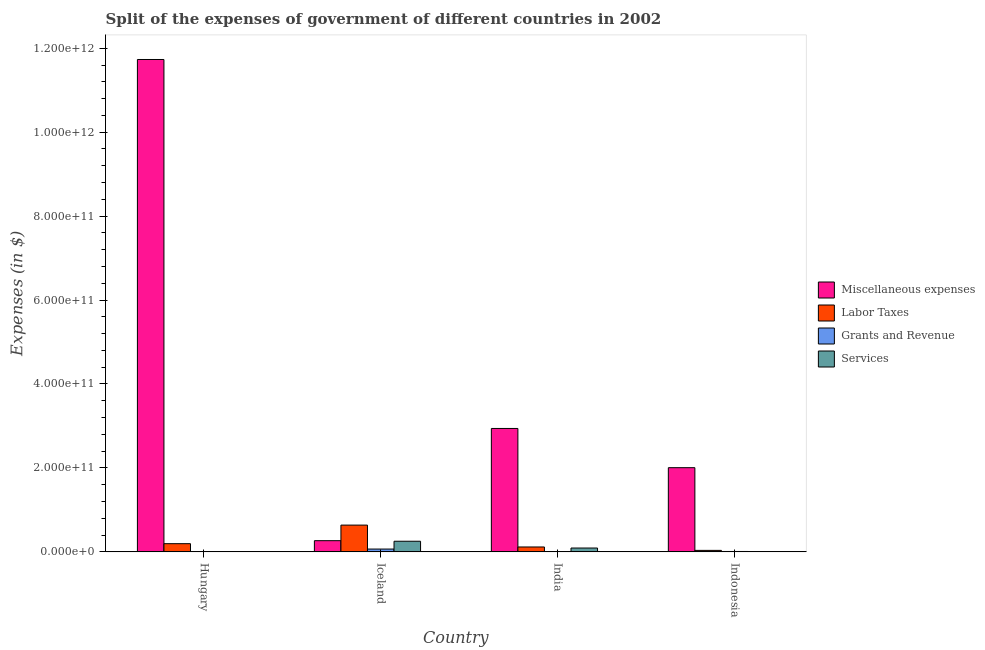How many groups of bars are there?
Provide a succinct answer. 4. Are the number of bars per tick equal to the number of legend labels?
Provide a succinct answer. Yes. Are the number of bars on each tick of the X-axis equal?
Provide a short and direct response. Yes. How many bars are there on the 1st tick from the left?
Provide a succinct answer. 4. How many bars are there on the 4th tick from the right?
Provide a succinct answer. 4. What is the label of the 1st group of bars from the left?
Ensure brevity in your answer.  Hungary. What is the amount spent on miscellaneous expenses in Indonesia?
Ensure brevity in your answer.  2.01e+11. Across all countries, what is the maximum amount spent on labor taxes?
Make the answer very short. 6.38e+1. Across all countries, what is the minimum amount spent on services?
Your response must be concise. 4.75e+07. What is the total amount spent on services in the graph?
Offer a terse response. 3.47e+1. What is the difference between the amount spent on labor taxes in India and that in Indonesia?
Give a very brief answer. 8.11e+09. What is the difference between the amount spent on miscellaneous expenses in Indonesia and the amount spent on services in Iceland?
Offer a very short reply. 1.75e+11. What is the average amount spent on services per country?
Keep it short and to the point. 8.68e+09. What is the difference between the amount spent on labor taxes and amount spent on miscellaneous expenses in Hungary?
Your response must be concise. -1.15e+12. What is the ratio of the amount spent on grants and revenue in Hungary to that in Iceland?
Make the answer very short. 0.03. Is the amount spent on miscellaneous expenses in Hungary less than that in Iceland?
Your answer should be compact. No. What is the difference between the highest and the second highest amount spent on labor taxes?
Your answer should be compact. 4.42e+1. What is the difference between the highest and the lowest amount spent on labor taxes?
Your response must be concise. 6.02e+1. In how many countries, is the amount spent on labor taxes greater than the average amount spent on labor taxes taken over all countries?
Make the answer very short. 1. Is it the case that in every country, the sum of the amount spent on miscellaneous expenses and amount spent on labor taxes is greater than the sum of amount spent on grants and revenue and amount spent on services?
Make the answer very short. No. What does the 1st bar from the left in Iceland represents?
Your response must be concise. Miscellaneous expenses. What does the 3rd bar from the right in India represents?
Give a very brief answer. Labor Taxes. How many bars are there?
Offer a very short reply. 16. Are all the bars in the graph horizontal?
Keep it short and to the point. No. How many countries are there in the graph?
Your response must be concise. 4. What is the difference between two consecutive major ticks on the Y-axis?
Your answer should be compact. 2.00e+11. Does the graph contain any zero values?
Keep it short and to the point. No. Where does the legend appear in the graph?
Your answer should be compact. Center right. How many legend labels are there?
Keep it short and to the point. 4. What is the title of the graph?
Offer a terse response. Split of the expenses of government of different countries in 2002. What is the label or title of the X-axis?
Offer a terse response. Country. What is the label or title of the Y-axis?
Give a very brief answer. Expenses (in $). What is the Expenses (in $) of Miscellaneous expenses in Hungary?
Give a very brief answer. 1.17e+12. What is the Expenses (in $) of Labor Taxes in Hungary?
Give a very brief answer. 1.95e+1. What is the Expenses (in $) of Grants and Revenue in Hungary?
Provide a short and direct response. 1.78e+08. What is the Expenses (in $) in Services in Hungary?
Offer a terse response. 1.82e+08. What is the Expenses (in $) of Miscellaneous expenses in Iceland?
Offer a terse response. 2.67e+1. What is the Expenses (in $) of Labor Taxes in Iceland?
Ensure brevity in your answer.  6.38e+1. What is the Expenses (in $) of Grants and Revenue in Iceland?
Offer a terse response. 6.73e+09. What is the Expenses (in $) of Services in Iceland?
Ensure brevity in your answer.  2.53e+1. What is the Expenses (in $) in Miscellaneous expenses in India?
Provide a succinct answer. 2.94e+11. What is the Expenses (in $) in Labor Taxes in India?
Provide a short and direct response. 1.17e+1. What is the Expenses (in $) in Grants and Revenue in India?
Offer a terse response. 5.36e+07. What is the Expenses (in $) of Services in India?
Offer a terse response. 9.18e+09. What is the Expenses (in $) of Miscellaneous expenses in Indonesia?
Make the answer very short. 2.01e+11. What is the Expenses (in $) in Labor Taxes in Indonesia?
Give a very brief answer. 3.57e+09. What is the Expenses (in $) of Grants and Revenue in Indonesia?
Your answer should be compact. 9.40e+08. What is the Expenses (in $) of Services in Indonesia?
Ensure brevity in your answer.  4.75e+07. Across all countries, what is the maximum Expenses (in $) in Miscellaneous expenses?
Provide a short and direct response. 1.17e+12. Across all countries, what is the maximum Expenses (in $) of Labor Taxes?
Your answer should be compact. 6.38e+1. Across all countries, what is the maximum Expenses (in $) of Grants and Revenue?
Make the answer very short. 6.73e+09. Across all countries, what is the maximum Expenses (in $) of Services?
Make the answer very short. 2.53e+1. Across all countries, what is the minimum Expenses (in $) in Miscellaneous expenses?
Your response must be concise. 2.67e+1. Across all countries, what is the minimum Expenses (in $) of Labor Taxes?
Provide a short and direct response. 3.57e+09. Across all countries, what is the minimum Expenses (in $) in Grants and Revenue?
Provide a succinct answer. 5.36e+07. Across all countries, what is the minimum Expenses (in $) in Services?
Provide a short and direct response. 4.75e+07. What is the total Expenses (in $) in Miscellaneous expenses in the graph?
Make the answer very short. 1.69e+12. What is the total Expenses (in $) of Labor Taxes in the graph?
Offer a very short reply. 9.86e+1. What is the total Expenses (in $) in Grants and Revenue in the graph?
Offer a very short reply. 7.90e+09. What is the total Expenses (in $) in Services in the graph?
Provide a succinct answer. 3.47e+1. What is the difference between the Expenses (in $) in Miscellaneous expenses in Hungary and that in Iceland?
Offer a terse response. 1.15e+12. What is the difference between the Expenses (in $) of Labor Taxes in Hungary and that in Iceland?
Give a very brief answer. -4.42e+1. What is the difference between the Expenses (in $) of Grants and Revenue in Hungary and that in Iceland?
Your answer should be compact. -6.55e+09. What is the difference between the Expenses (in $) of Services in Hungary and that in Iceland?
Your answer should be compact. -2.51e+1. What is the difference between the Expenses (in $) of Miscellaneous expenses in Hungary and that in India?
Provide a short and direct response. 8.79e+11. What is the difference between the Expenses (in $) in Labor Taxes in Hungary and that in India?
Ensure brevity in your answer.  7.86e+09. What is the difference between the Expenses (in $) in Grants and Revenue in Hungary and that in India?
Make the answer very short. 1.24e+08. What is the difference between the Expenses (in $) in Services in Hungary and that in India?
Your answer should be compact. -9.00e+09. What is the difference between the Expenses (in $) in Miscellaneous expenses in Hungary and that in Indonesia?
Give a very brief answer. 9.73e+11. What is the difference between the Expenses (in $) of Labor Taxes in Hungary and that in Indonesia?
Make the answer very short. 1.60e+1. What is the difference between the Expenses (in $) of Grants and Revenue in Hungary and that in Indonesia?
Your answer should be compact. -7.63e+08. What is the difference between the Expenses (in $) of Services in Hungary and that in Indonesia?
Your answer should be very brief. 1.35e+08. What is the difference between the Expenses (in $) of Miscellaneous expenses in Iceland and that in India?
Your answer should be compact. -2.67e+11. What is the difference between the Expenses (in $) of Labor Taxes in Iceland and that in India?
Provide a short and direct response. 5.21e+1. What is the difference between the Expenses (in $) in Grants and Revenue in Iceland and that in India?
Your response must be concise. 6.67e+09. What is the difference between the Expenses (in $) in Services in Iceland and that in India?
Provide a short and direct response. 1.61e+1. What is the difference between the Expenses (in $) in Miscellaneous expenses in Iceland and that in Indonesia?
Keep it short and to the point. -1.74e+11. What is the difference between the Expenses (in $) of Labor Taxes in Iceland and that in Indonesia?
Offer a terse response. 6.02e+1. What is the difference between the Expenses (in $) in Grants and Revenue in Iceland and that in Indonesia?
Your response must be concise. 5.79e+09. What is the difference between the Expenses (in $) in Services in Iceland and that in Indonesia?
Offer a very short reply. 2.53e+1. What is the difference between the Expenses (in $) in Miscellaneous expenses in India and that in Indonesia?
Give a very brief answer. 9.34e+1. What is the difference between the Expenses (in $) in Labor Taxes in India and that in Indonesia?
Provide a short and direct response. 8.11e+09. What is the difference between the Expenses (in $) in Grants and Revenue in India and that in Indonesia?
Keep it short and to the point. -8.87e+08. What is the difference between the Expenses (in $) in Services in India and that in Indonesia?
Ensure brevity in your answer.  9.13e+09. What is the difference between the Expenses (in $) of Miscellaneous expenses in Hungary and the Expenses (in $) of Labor Taxes in Iceland?
Ensure brevity in your answer.  1.11e+12. What is the difference between the Expenses (in $) of Miscellaneous expenses in Hungary and the Expenses (in $) of Grants and Revenue in Iceland?
Your answer should be compact. 1.17e+12. What is the difference between the Expenses (in $) in Miscellaneous expenses in Hungary and the Expenses (in $) in Services in Iceland?
Make the answer very short. 1.15e+12. What is the difference between the Expenses (in $) of Labor Taxes in Hungary and the Expenses (in $) of Grants and Revenue in Iceland?
Provide a short and direct response. 1.28e+1. What is the difference between the Expenses (in $) of Labor Taxes in Hungary and the Expenses (in $) of Services in Iceland?
Make the answer very short. -5.78e+09. What is the difference between the Expenses (in $) of Grants and Revenue in Hungary and the Expenses (in $) of Services in Iceland?
Offer a terse response. -2.51e+1. What is the difference between the Expenses (in $) of Miscellaneous expenses in Hungary and the Expenses (in $) of Labor Taxes in India?
Your answer should be compact. 1.16e+12. What is the difference between the Expenses (in $) in Miscellaneous expenses in Hungary and the Expenses (in $) in Grants and Revenue in India?
Provide a short and direct response. 1.17e+12. What is the difference between the Expenses (in $) of Miscellaneous expenses in Hungary and the Expenses (in $) of Services in India?
Your answer should be very brief. 1.16e+12. What is the difference between the Expenses (in $) of Labor Taxes in Hungary and the Expenses (in $) of Grants and Revenue in India?
Your response must be concise. 1.95e+1. What is the difference between the Expenses (in $) of Labor Taxes in Hungary and the Expenses (in $) of Services in India?
Ensure brevity in your answer.  1.04e+1. What is the difference between the Expenses (in $) in Grants and Revenue in Hungary and the Expenses (in $) in Services in India?
Your answer should be compact. -9.00e+09. What is the difference between the Expenses (in $) of Miscellaneous expenses in Hungary and the Expenses (in $) of Labor Taxes in Indonesia?
Your response must be concise. 1.17e+12. What is the difference between the Expenses (in $) in Miscellaneous expenses in Hungary and the Expenses (in $) in Grants and Revenue in Indonesia?
Keep it short and to the point. 1.17e+12. What is the difference between the Expenses (in $) in Miscellaneous expenses in Hungary and the Expenses (in $) in Services in Indonesia?
Provide a succinct answer. 1.17e+12. What is the difference between the Expenses (in $) in Labor Taxes in Hungary and the Expenses (in $) in Grants and Revenue in Indonesia?
Your response must be concise. 1.86e+1. What is the difference between the Expenses (in $) of Labor Taxes in Hungary and the Expenses (in $) of Services in Indonesia?
Your response must be concise. 1.95e+1. What is the difference between the Expenses (in $) in Grants and Revenue in Hungary and the Expenses (in $) in Services in Indonesia?
Offer a terse response. 1.30e+08. What is the difference between the Expenses (in $) of Miscellaneous expenses in Iceland and the Expenses (in $) of Labor Taxes in India?
Provide a short and direct response. 1.50e+1. What is the difference between the Expenses (in $) of Miscellaneous expenses in Iceland and the Expenses (in $) of Grants and Revenue in India?
Your response must be concise. 2.66e+1. What is the difference between the Expenses (in $) in Miscellaneous expenses in Iceland and the Expenses (in $) in Services in India?
Provide a succinct answer. 1.75e+1. What is the difference between the Expenses (in $) in Labor Taxes in Iceland and the Expenses (in $) in Grants and Revenue in India?
Offer a very short reply. 6.37e+1. What is the difference between the Expenses (in $) in Labor Taxes in Iceland and the Expenses (in $) in Services in India?
Provide a succinct answer. 5.46e+1. What is the difference between the Expenses (in $) of Grants and Revenue in Iceland and the Expenses (in $) of Services in India?
Provide a succinct answer. -2.46e+09. What is the difference between the Expenses (in $) in Miscellaneous expenses in Iceland and the Expenses (in $) in Labor Taxes in Indonesia?
Offer a very short reply. 2.31e+1. What is the difference between the Expenses (in $) in Miscellaneous expenses in Iceland and the Expenses (in $) in Grants and Revenue in Indonesia?
Make the answer very short. 2.57e+1. What is the difference between the Expenses (in $) of Miscellaneous expenses in Iceland and the Expenses (in $) of Services in Indonesia?
Provide a succinct answer. 2.66e+1. What is the difference between the Expenses (in $) of Labor Taxes in Iceland and the Expenses (in $) of Grants and Revenue in Indonesia?
Offer a terse response. 6.28e+1. What is the difference between the Expenses (in $) in Labor Taxes in Iceland and the Expenses (in $) in Services in Indonesia?
Offer a terse response. 6.37e+1. What is the difference between the Expenses (in $) of Grants and Revenue in Iceland and the Expenses (in $) of Services in Indonesia?
Make the answer very short. 6.68e+09. What is the difference between the Expenses (in $) in Miscellaneous expenses in India and the Expenses (in $) in Labor Taxes in Indonesia?
Your answer should be compact. 2.90e+11. What is the difference between the Expenses (in $) of Miscellaneous expenses in India and the Expenses (in $) of Grants and Revenue in Indonesia?
Provide a succinct answer. 2.93e+11. What is the difference between the Expenses (in $) in Miscellaneous expenses in India and the Expenses (in $) in Services in Indonesia?
Offer a terse response. 2.94e+11. What is the difference between the Expenses (in $) of Labor Taxes in India and the Expenses (in $) of Grants and Revenue in Indonesia?
Keep it short and to the point. 1.07e+1. What is the difference between the Expenses (in $) of Labor Taxes in India and the Expenses (in $) of Services in Indonesia?
Keep it short and to the point. 1.16e+1. What is the difference between the Expenses (in $) in Grants and Revenue in India and the Expenses (in $) in Services in Indonesia?
Ensure brevity in your answer.  6.10e+06. What is the average Expenses (in $) of Miscellaneous expenses per country?
Ensure brevity in your answer.  4.24e+11. What is the average Expenses (in $) of Labor Taxes per country?
Make the answer very short. 2.46e+1. What is the average Expenses (in $) of Grants and Revenue per country?
Offer a very short reply. 1.97e+09. What is the average Expenses (in $) in Services per country?
Make the answer very short. 8.68e+09. What is the difference between the Expenses (in $) in Miscellaneous expenses and Expenses (in $) in Labor Taxes in Hungary?
Your answer should be compact. 1.15e+12. What is the difference between the Expenses (in $) of Miscellaneous expenses and Expenses (in $) of Grants and Revenue in Hungary?
Keep it short and to the point. 1.17e+12. What is the difference between the Expenses (in $) of Miscellaneous expenses and Expenses (in $) of Services in Hungary?
Keep it short and to the point. 1.17e+12. What is the difference between the Expenses (in $) of Labor Taxes and Expenses (in $) of Grants and Revenue in Hungary?
Offer a terse response. 1.94e+1. What is the difference between the Expenses (in $) in Labor Taxes and Expenses (in $) in Services in Hungary?
Make the answer very short. 1.94e+1. What is the difference between the Expenses (in $) of Grants and Revenue and Expenses (in $) of Services in Hungary?
Your answer should be compact. -4.40e+06. What is the difference between the Expenses (in $) of Miscellaneous expenses and Expenses (in $) of Labor Taxes in Iceland?
Your answer should be compact. -3.71e+1. What is the difference between the Expenses (in $) in Miscellaneous expenses and Expenses (in $) in Grants and Revenue in Iceland?
Provide a succinct answer. 1.99e+1. What is the difference between the Expenses (in $) of Miscellaneous expenses and Expenses (in $) of Services in Iceland?
Offer a terse response. 1.34e+09. What is the difference between the Expenses (in $) in Labor Taxes and Expenses (in $) in Grants and Revenue in Iceland?
Your answer should be compact. 5.70e+1. What is the difference between the Expenses (in $) of Labor Taxes and Expenses (in $) of Services in Iceland?
Make the answer very short. 3.85e+1. What is the difference between the Expenses (in $) in Grants and Revenue and Expenses (in $) in Services in Iceland?
Offer a terse response. -1.86e+1. What is the difference between the Expenses (in $) of Miscellaneous expenses and Expenses (in $) of Labor Taxes in India?
Your response must be concise. 2.82e+11. What is the difference between the Expenses (in $) in Miscellaneous expenses and Expenses (in $) in Grants and Revenue in India?
Offer a terse response. 2.94e+11. What is the difference between the Expenses (in $) in Miscellaneous expenses and Expenses (in $) in Services in India?
Offer a very short reply. 2.85e+11. What is the difference between the Expenses (in $) in Labor Taxes and Expenses (in $) in Grants and Revenue in India?
Your answer should be very brief. 1.16e+1. What is the difference between the Expenses (in $) of Labor Taxes and Expenses (in $) of Services in India?
Offer a very short reply. 2.50e+09. What is the difference between the Expenses (in $) in Grants and Revenue and Expenses (in $) in Services in India?
Provide a succinct answer. -9.13e+09. What is the difference between the Expenses (in $) in Miscellaneous expenses and Expenses (in $) in Labor Taxes in Indonesia?
Provide a short and direct response. 1.97e+11. What is the difference between the Expenses (in $) in Miscellaneous expenses and Expenses (in $) in Grants and Revenue in Indonesia?
Provide a short and direct response. 2.00e+11. What is the difference between the Expenses (in $) of Miscellaneous expenses and Expenses (in $) of Services in Indonesia?
Offer a terse response. 2.01e+11. What is the difference between the Expenses (in $) in Labor Taxes and Expenses (in $) in Grants and Revenue in Indonesia?
Ensure brevity in your answer.  2.63e+09. What is the difference between the Expenses (in $) in Labor Taxes and Expenses (in $) in Services in Indonesia?
Offer a terse response. 3.52e+09. What is the difference between the Expenses (in $) in Grants and Revenue and Expenses (in $) in Services in Indonesia?
Provide a succinct answer. 8.93e+08. What is the ratio of the Expenses (in $) in Miscellaneous expenses in Hungary to that in Iceland?
Provide a short and direct response. 44.01. What is the ratio of the Expenses (in $) of Labor Taxes in Hungary to that in Iceland?
Your answer should be compact. 0.31. What is the ratio of the Expenses (in $) of Grants and Revenue in Hungary to that in Iceland?
Your response must be concise. 0.03. What is the ratio of the Expenses (in $) of Services in Hungary to that in Iceland?
Provide a succinct answer. 0.01. What is the ratio of the Expenses (in $) of Miscellaneous expenses in Hungary to that in India?
Keep it short and to the point. 3.99. What is the ratio of the Expenses (in $) in Labor Taxes in Hungary to that in India?
Your answer should be very brief. 1.67. What is the ratio of the Expenses (in $) of Grants and Revenue in Hungary to that in India?
Provide a short and direct response. 3.32. What is the ratio of the Expenses (in $) of Services in Hungary to that in India?
Your answer should be very brief. 0.02. What is the ratio of the Expenses (in $) of Miscellaneous expenses in Hungary to that in Indonesia?
Keep it short and to the point. 5.85. What is the ratio of the Expenses (in $) in Labor Taxes in Hungary to that in Indonesia?
Provide a succinct answer. 5.47. What is the ratio of the Expenses (in $) in Grants and Revenue in Hungary to that in Indonesia?
Give a very brief answer. 0.19. What is the ratio of the Expenses (in $) of Services in Hungary to that in Indonesia?
Your answer should be very brief. 3.83. What is the ratio of the Expenses (in $) of Miscellaneous expenses in Iceland to that in India?
Your answer should be very brief. 0.09. What is the ratio of the Expenses (in $) of Labor Taxes in Iceland to that in India?
Provide a short and direct response. 5.46. What is the ratio of the Expenses (in $) of Grants and Revenue in Iceland to that in India?
Give a very brief answer. 125.49. What is the ratio of the Expenses (in $) in Services in Iceland to that in India?
Offer a terse response. 2.76. What is the ratio of the Expenses (in $) in Miscellaneous expenses in Iceland to that in Indonesia?
Your answer should be very brief. 0.13. What is the ratio of the Expenses (in $) of Labor Taxes in Iceland to that in Indonesia?
Provide a short and direct response. 17.86. What is the ratio of the Expenses (in $) in Grants and Revenue in Iceland to that in Indonesia?
Give a very brief answer. 7.15. What is the ratio of the Expenses (in $) of Services in Iceland to that in Indonesia?
Provide a succinct answer. 533.05. What is the ratio of the Expenses (in $) of Miscellaneous expenses in India to that in Indonesia?
Your response must be concise. 1.47. What is the ratio of the Expenses (in $) in Labor Taxes in India to that in Indonesia?
Ensure brevity in your answer.  3.27. What is the ratio of the Expenses (in $) of Grants and Revenue in India to that in Indonesia?
Give a very brief answer. 0.06. What is the ratio of the Expenses (in $) in Services in India to that in Indonesia?
Offer a terse response. 193.31. What is the difference between the highest and the second highest Expenses (in $) in Miscellaneous expenses?
Give a very brief answer. 8.79e+11. What is the difference between the highest and the second highest Expenses (in $) in Labor Taxes?
Your answer should be compact. 4.42e+1. What is the difference between the highest and the second highest Expenses (in $) of Grants and Revenue?
Offer a terse response. 5.79e+09. What is the difference between the highest and the second highest Expenses (in $) of Services?
Provide a succinct answer. 1.61e+1. What is the difference between the highest and the lowest Expenses (in $) in Miscellaneous expenses?
Your answer should be compact. 1.15e+12. What is the difference between the highest and the lowest Expenses (in $) in Labor Taxes?
Keep it short and to the point. 6.02e+1. What is the difference between the highest and the lowest Expenses (in $) of Grants and Revenue?
Offer a terse response. 6.67e+09. What is the difference between the highest and the lowest Expenses (in $) of Services?
Your response must be concise. 2.53e+1. 